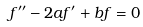<formula> <loc_0><loc_0><loc_500><loc_500>f ^ { \prime \prime } - 2 a f ^ { \prime } + b f = 0</formula> 